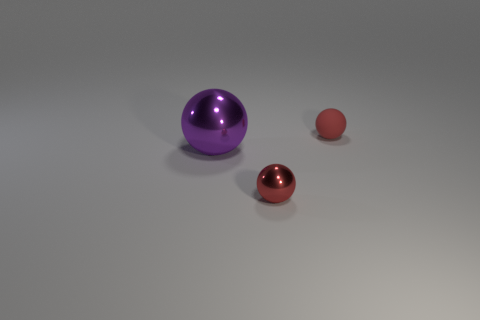Add 1 red rubber cubes. How many objects exist? 4 Add 2 purple balls. How many purple balls are left? 3 Add 3 small blue matte things. How many small blue matte things exist? 3 Subtract 0 cyan cylinders. How many objects are left? 3 Subtract all tiny things. Subtract all cylinders. How many objects are left? 1 